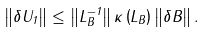<formula> <loc_0><loc_0><loc_500><loc_500>\left \| \delta U _ { 1 } \right \| \leq \left \| L _ { B } ^ { - 1 } \right \| \kappa \left ( L _ { B } \right ) \left \| \delta B \right \| .</formula> 